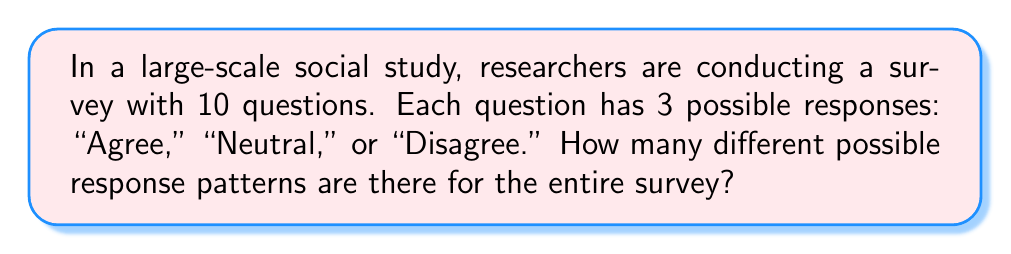What is the answer to this math problem? Let's approach this step-by-step:

1) First, we need to understand what the question is asking. We're looking for the total number of possible ways a participant could respond to all 10 questions.

2) For each individual question, there are 3 possible responses.

3) This scenario is a perfect application of the multiplication principle in combinatorics. When we have a series of independent choices, and we want to know the total number of possible outcomes, we multiply the number of options for each choice.

4) In this case, we have 10 questions (choices), and each has 3 possible responses (options).

5) Therefore, the total number of possible response patterns is:

   $$ 3 \times 3 \times 3 \times ... \times 3 $$ (10 times)

6) This can be written more concisely as an exponent:

   $$ 3^{10} $$

7) To calculate this:
   $$ 3^{10} = 3 \times 3 \times 3 \times 3 \times 3 \times 3 \times 3 \times 3 \times 3 \times 3 = 59,049 $$

Thus, there are 59,049 possible response patterns for the entire survey.
Answer: $3^{10} = 59,049$ 